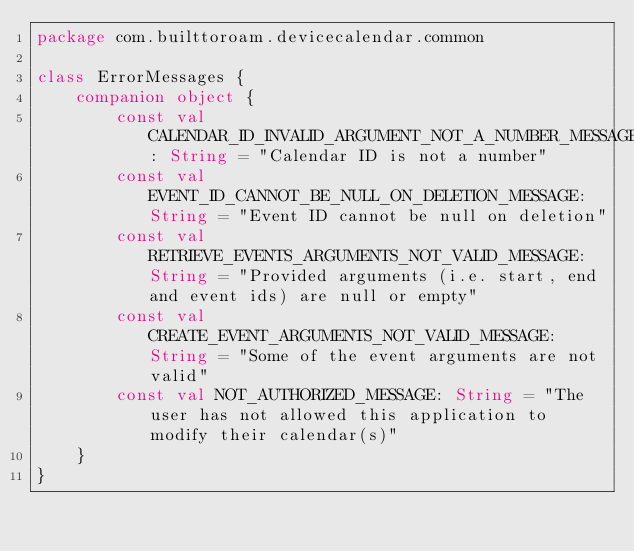Convert code to text. <code><loc_0><loc_0><loc_500><loc_500><_Kotlin_>package com.builttoroam.devicecalendar.common

class ErrorMessages {
    companion object {
        const val CALENDAR_ID_INVALID_ARGUMENT_NOT_A_NUMBER_MESSAGE: String = "Calendar ID is not a number"
        const val EVENT_ID_CANNOT_BE_NULL_ON_DELETION_MESSAGE: String = "Event ID cannot be null on deletion"
        const val RETRIEVE_EVENTS_ARGUMENTS_NOT_VALID_MESSAGE: String = "Provided arguments (i.e. start, end and event ids) are null or empty"
        const val CREATE_EVENT_ARGUMENTS_NOT_VALID_MESSAGE: String = "Some of the event arguments are not valid"
        const val NOT_AUTHORIZED_MESSAGE: String = "The user has not allowed this application to modify their calendar(s)"
    }
}
</code> 